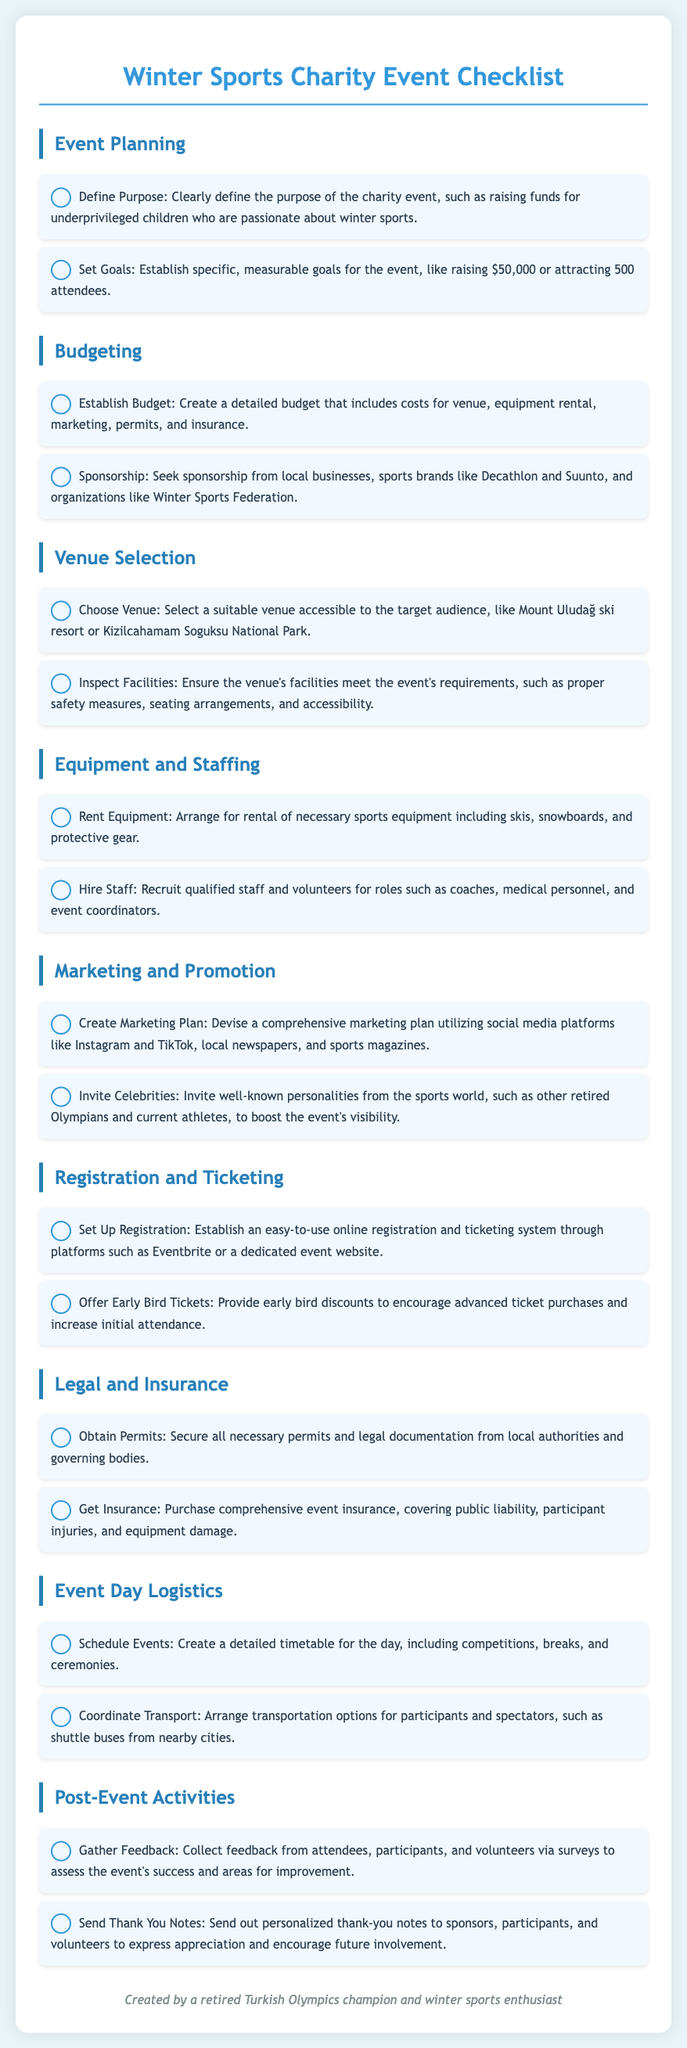What is the purpose of the charity event? The purpose of the charity event is clearly defined in the document as raising funds for underprivileged children who are passionate about winter sports.
Answer: Raising funds for underprivileged children What is the budget goal for the event? The document mentions establishing specific, measurable goals, such as raising $50,000 or attracting 500 attendees.
Answer: $50,000 Where can the event be held? The checklist suggests suitable venues like Mount Uludağ ski resort or Kizilcahamam Soguksu National Park for hosting the event.
Answer: Mount Uludağ ski resort What type of insurance is recommended? The document specifies purchasing comprehensive event insurance covering public liability, participant injuries, and equipment damage.
Answer: Comprehensive event insurance What is a key marketing strategy suggested? The document recommends creating a comprehensive marketing plan utilizing social media platforms like Instagram and TikTok, local newspapers, and sports magazines.
Answer: Comprehensive marketing plan How should profitability be assessed after the event? One of the post-event activities includes collecting feedback from attendees, participants, and volunteers via surveys to assess the event's success and areas for improvement.
Answer: Gather feedback Who should be invited to boost event visibility? The checklist suggests inviting well-known personalities from the sports world, such as other retired Olympians and current athletes.
Answer: Well-known personalities What is an early ticket sales strategy? The document advises offering early bird discounts to encourage advanced ticket purchases and increase initial attendance.
Answer: Early bird discounts 